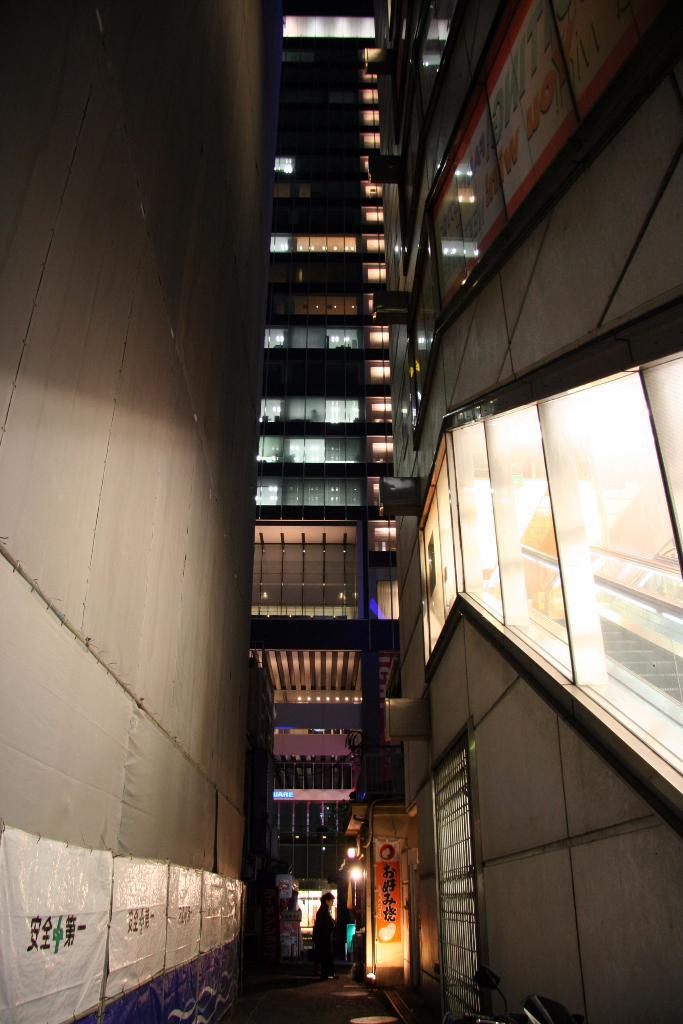What type of structure is visible in the image? There is a building in the image. What is located on the left side of the image? There is a wall on the left side of the image. What can be seen on the wall? There are white color posters on the wall. What is blocking the path in the image? There is a person standing in the path. What type of reaction does the bee have when it sees the person standing in the path? There is no bee present in the image, so it is not possible to determine its reaction. 